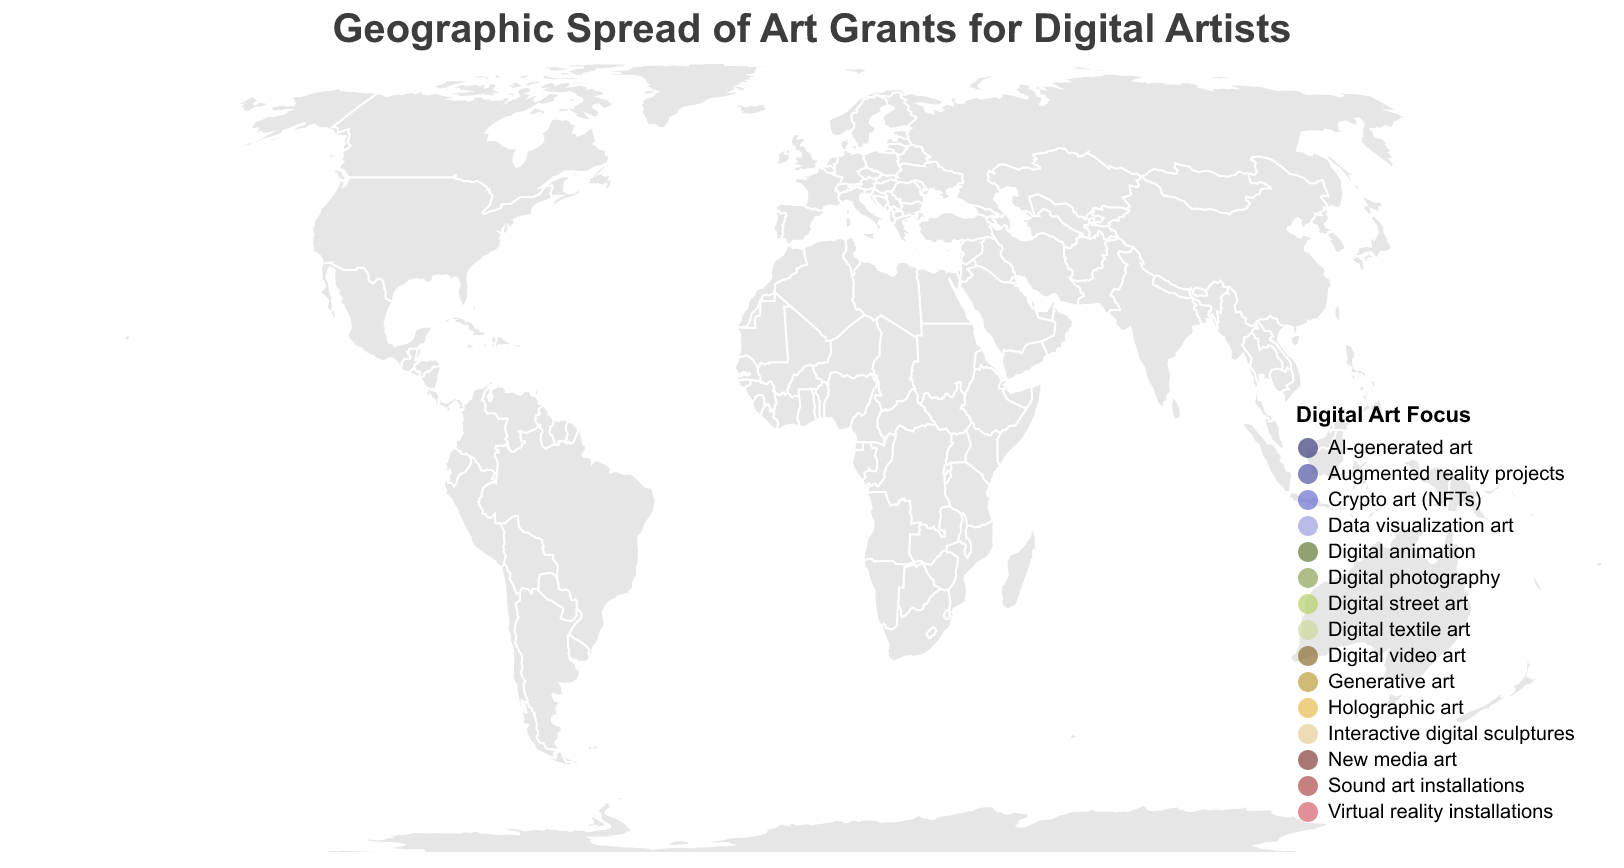What is the title of the geographic plot? The title of the plot is usually located at the top, giving a quick summary of what the data represents.
Answer: Geographic Spread of Art Grants for Digital Artists Which country has received the highest grant amount, and how much is it? To find the highest grant amount, you observe the size of the circles representing each country. The USA has the largest circle, indicating the highest grant amount.
Answer: USA, $250,000 How many countries are shown in the plot? Count the number of unique locations (circles) on the map, each representing a country.
Answer: 15 Which region in Asia has secured a grant for holographic art, and how much is the grant amount? Look for the region with the digital art focus on holographic art within the Asian continent. Seoul, South Korea, matches this criterion.
Answer: Seoul, $110,000 What is the Digital Art Focus for the grant awarded in Sydney, Australia? The color and tooltip associated with the circle in Sydney, Australia, indicate the digital art focus. It is shown to focus on Augmented reality projects.
Answer: Augmented reality projects What is the total grant amount for all European countries combined? Calculate the sum of grant amounts by identifying the relevant countries in Europe: UK (180,000) + Germany (150,000) + France (130,000) + Netherlands (90,000) + Spain (80,000) + Italy (70,000) + Sweden (95,000).
Answer: $795,000 Which country in South America received a grant, and for what Digital Art Focus? Identify the unique circle located within South America. Brazil is shown with a grant focusing on Digital street art.
Answer: Brazil, Digital street art Compare the grant amounts between London (UK) and Tokyo (Japan). Which one is higher, and by how much? Refer to the circles for London and Tokyo and compare the values. London received $180,000 and Tokyo $200,000.
Answer: Tokyo by $20,000 In terms of funding organizations, which one has provided a grant for digital textile art? Check the tooltip details related to Digital textile art. India Foundation for the Arts in Mumbai provided this grant.
Answer: India Foundation for the Arts Which country has the smallest grant amount and what Digital Art Focus does it have? Identify the smallest circle on the map which corresponds to the smallest grant amount. Mumbai, India has the smallest grant amount with a focus on Digital textile art.
Answer: India, Digital textile art 